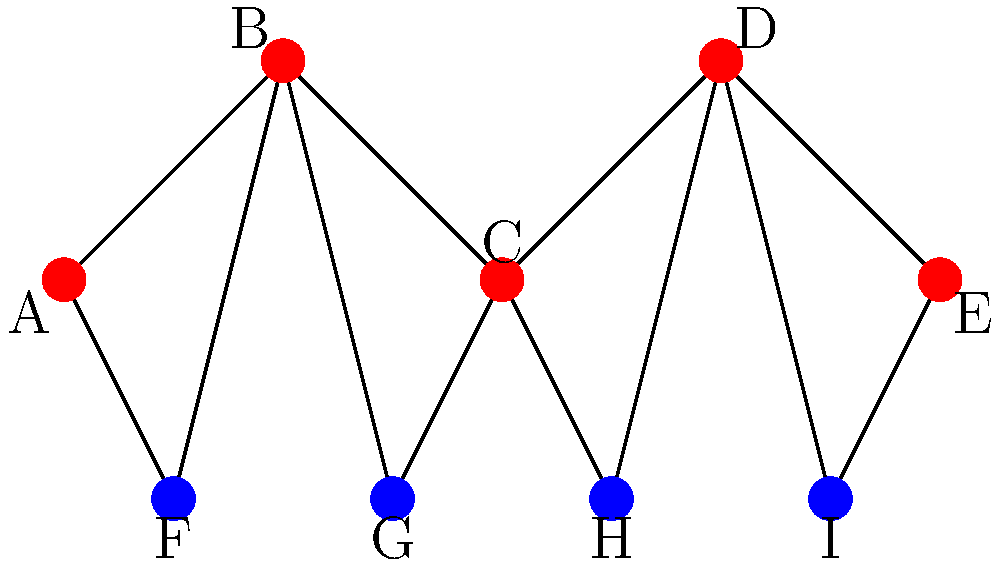In the given gene interaction network visualization, how many distinct communities can be identified using the Girvan-Newman algorithm, assuming edges between nodes of different colors have higher betweenness centrality? To identify communities using the Girvan-Newman algorithm in this gene interaction network, we follow these steps:

1. Observe the network structure: The network consists of 9 nodes (A to I) with two distinct color groups (red and blue).

2. Understand the Girvan-Newman algorithm: This algorithm identifies communities by progressively removing edges with the highest betweenness centrality.

3. Identify high betweenness centrality edges: As per the question, edges between nodes of different colors have higher betweenness centrality. These are:
   - A-F, B-F
   - B-G, C-G
   - C-H, D-H
   - D-I, E-I

4. Remove these high betweenness centrality edges: After removal, we are left with two distinct subgraphs:
   - Subgraph 1: A-B-C-D-E (red nodes)
   - Subgraph 2: F-G-H-I (blue nodes)

5. Identify communities: Each of these subgraphs represents a distinct community in the network.

Therefore, the Girvan-Newman algorithm would identify 2 distinct communities in this gene interaction network.
Answer: 2 communities 